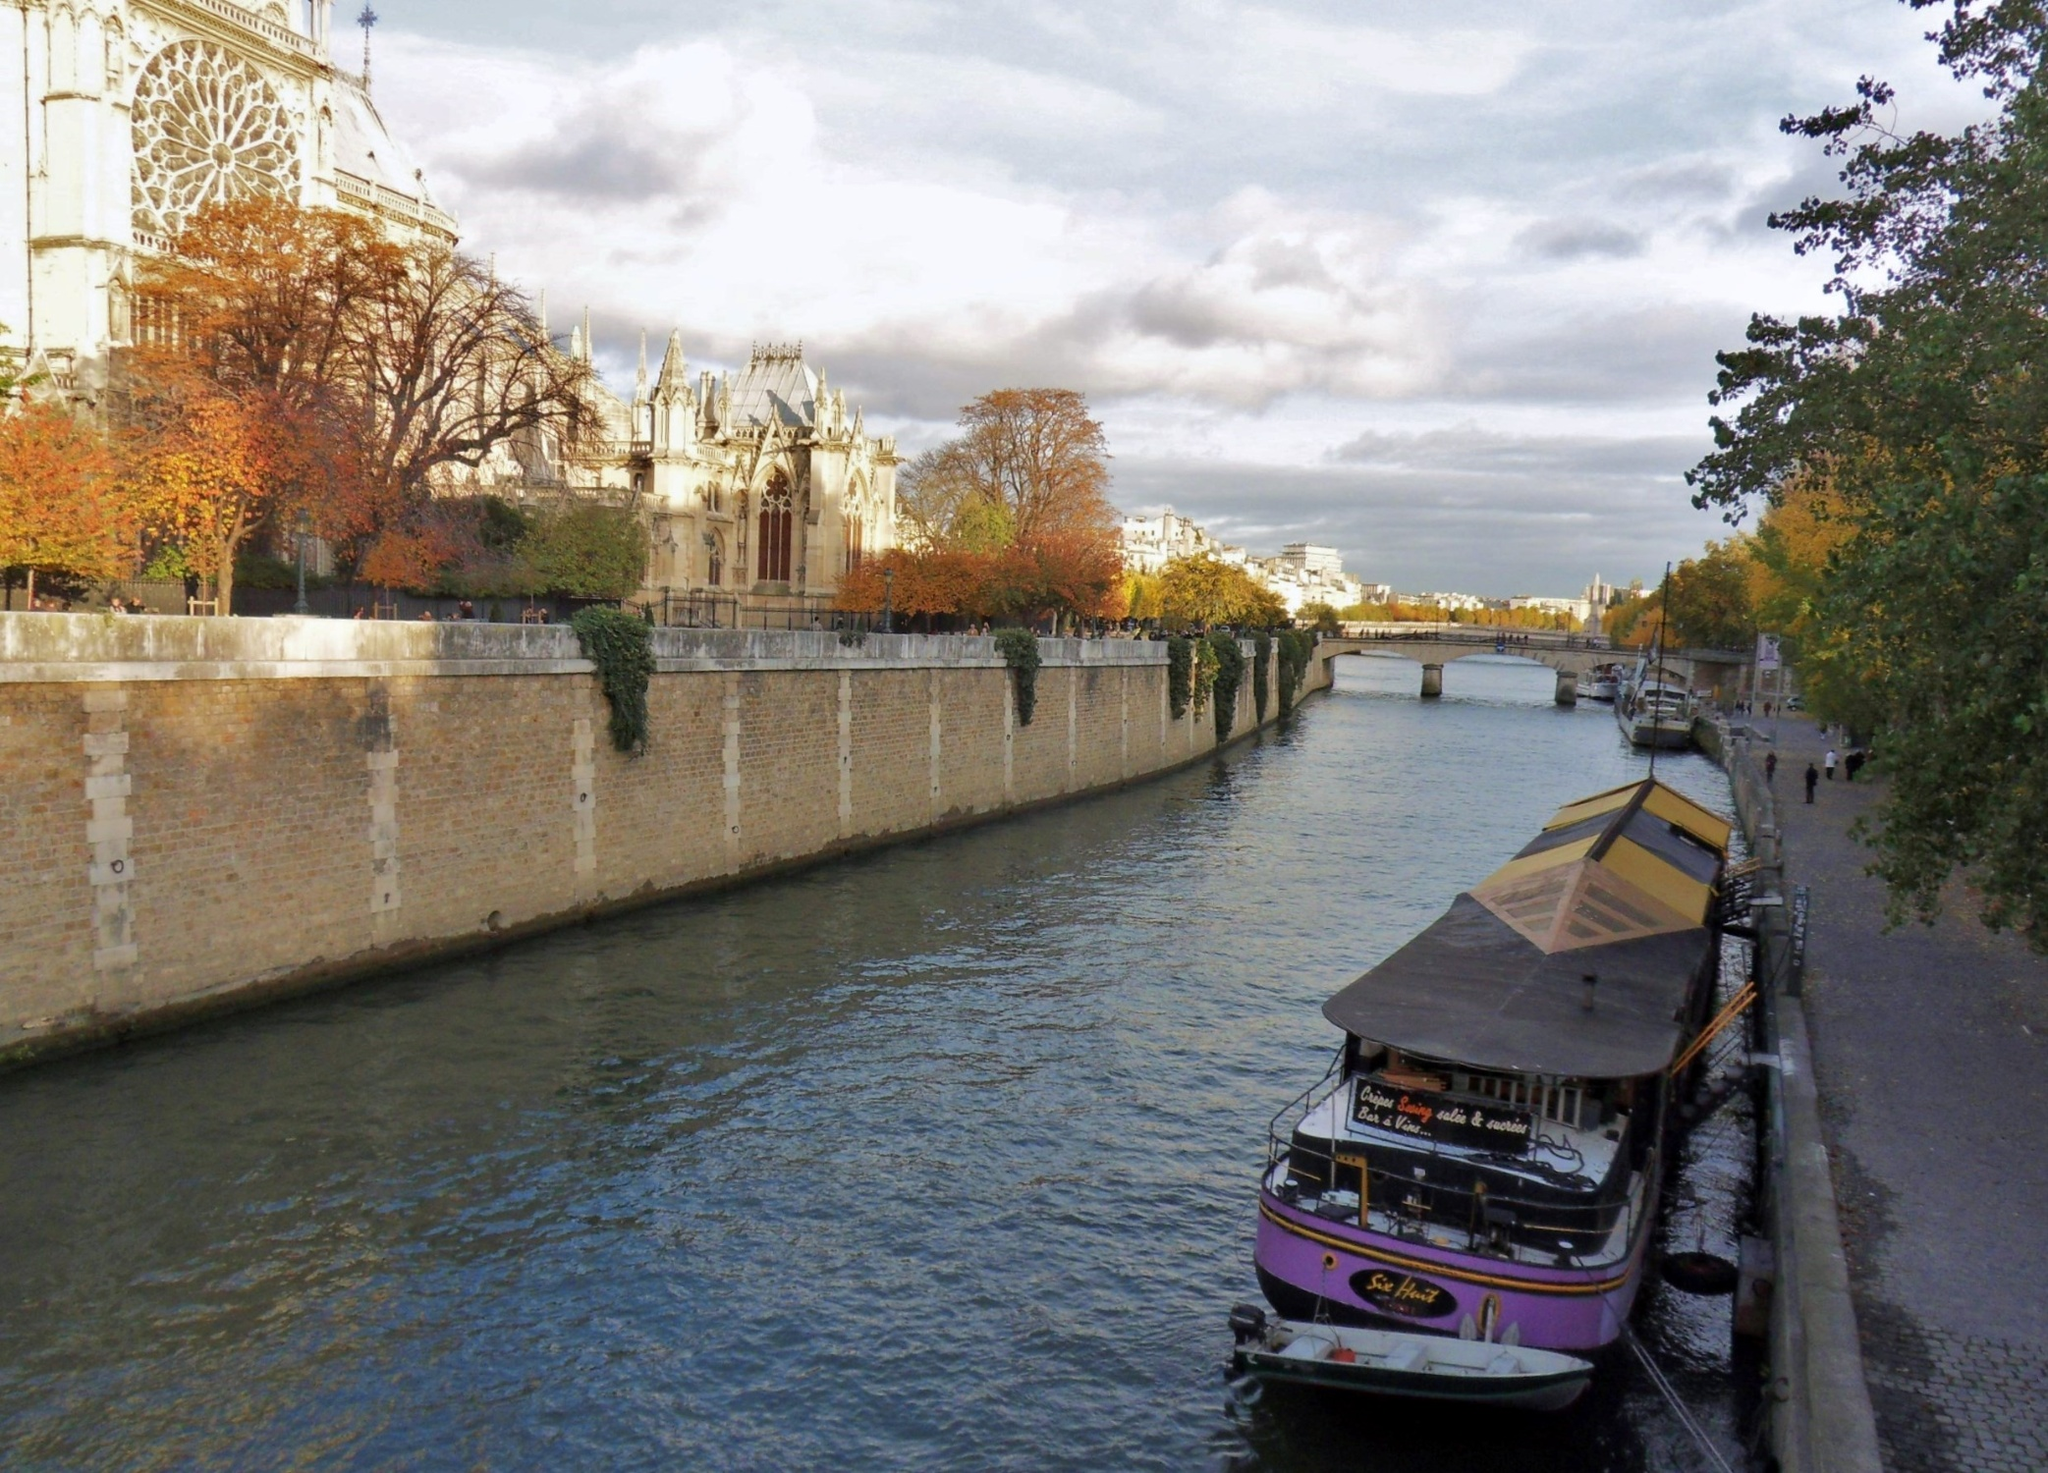What might you imagine the people in the background are doing? The people in the background are likely taking a leisurely stroll along the Seine, enjoying the crisp autumn air and the vibrant fall colors of the trees lining the river. Some might be tourists, capturing memories with their cameras, while others could be Parisians on their daily walk, soaking in the panoramic views of their beautiful city. The serene and contemplative atmosphere of the scene suggests a moment of relaxation and reflection. What stories could the Notre Dame Cathedral tell us? The Notre Dame Cathedral, an iconic gothic structure, could tell stories spanning centuries. It has witnessed historical events from royal coronations to revolutionary uprisings. The cathedral could recount the painstaking efforts of medieval craftsmen who labored to construct its awe-inspiring architecture, complete with gargoyles and stained glass windows. It could share tales of famous literary works, like Victor Hugo's 'The Hunchback of Notre Dame', which immortalized the cathedral in the annals of literature. The spire, though now lost in the 2019 fire, was once a testament to resilience and rebirth, having been restored in the 19th century after the tumult of the French Revolution. Every stone, every carving, every weathered facade of the Notre Dame speaks volumes of endurance, faith, and the indomitable spirit of Paris. 